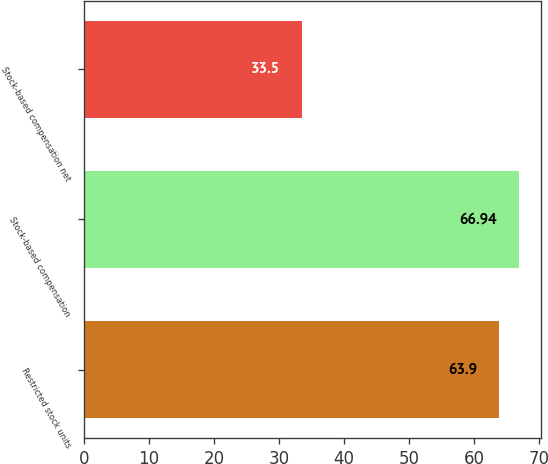Convert chart to OTSL. <chart><loc_0><loc_0><loc_500><loc_500><bar_chart><fcel>Restricted stock units<fcel>Stock-based compensation<fcel>Stock-based compensation net<nl><fcel>63.9<fcel>66.94<fcel>33.5<nl></chart> 